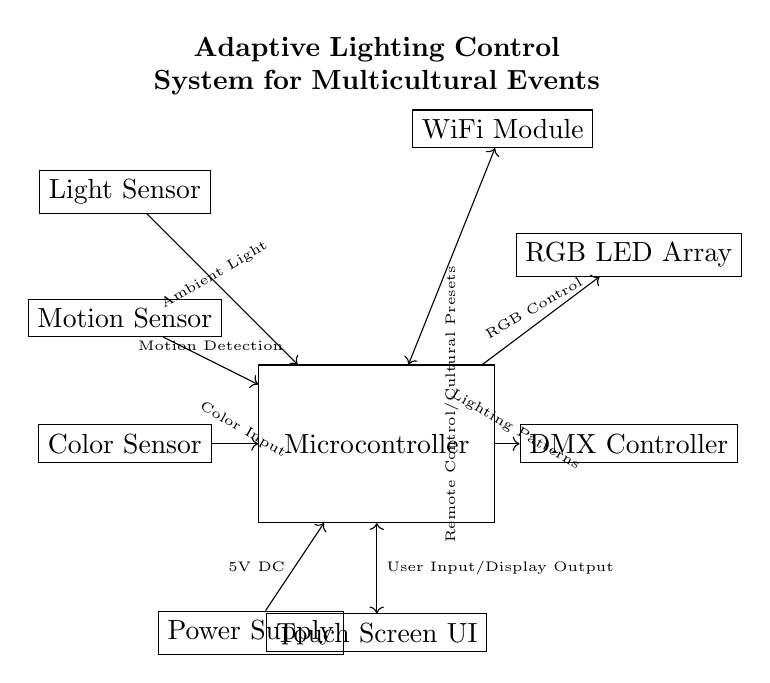What is the main component of this circuit? The main component is the Microcontroller, which is centrally located and communicates with other components.
Answer: Microcontroller How many sensors are present in this circuit? There are three sensors: a Light Sensor, a Motion Sensor, and a Color Sensor, each performing different functions related to ambient light, movement, and color recognition.
Answer: Three What type of lighting device is used in this circuit? The circuit employs an RGB LED Array, which is capable of producing various colors by mixing red, green, and blue light.
Answer: RGB LED Array What is the purpose of the WiFi module in the system? The WiFi Module allows for remote control and facilitates cultural presets, enabling users to control the lighting according to different cultural events.
Answer: Remote Control/Cultural Presets What is the voltage supply for the Microcontroller? The voltage supply is 5V DC, indicated by the connection from the Power Supply to the Microcontroller.
Answer: 5V DC How does the Microcontroller interact with the user interface? The Microcontroller interacts with the Touch Screen User Interface through bidirectional communication, allowing user input and display output.
Answer: User Input/Display Output 